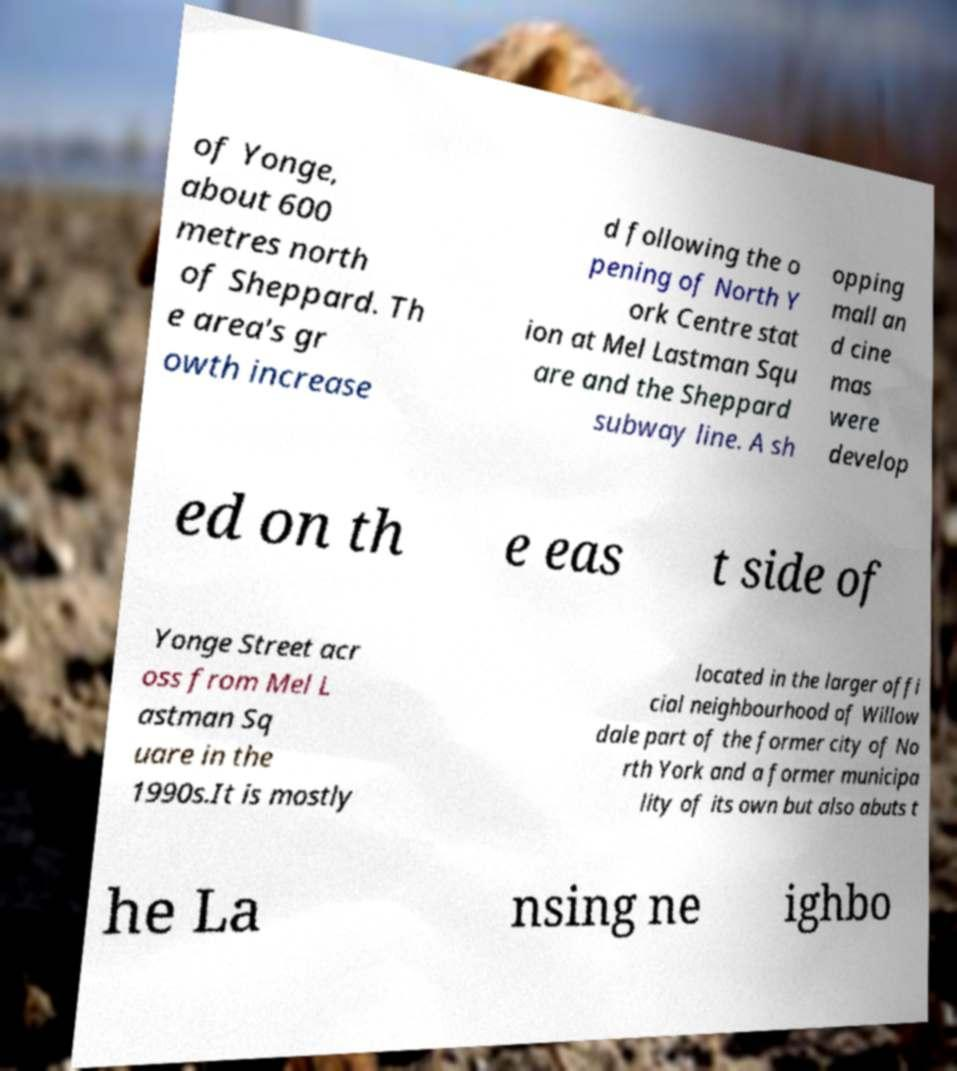Please read and relay the text visible in this image. What does it say? of Yonge, about 600 metres north of Sheppard. Th e area's gr owth increase d following the o pening of North Y ork Centre stat ion at Mel Lastman Squ are and the Sheppard subway line. A sh opping mall an d cine mas were develop ed on th e eas t side of Yonge Street acr oss from Mel L astman Sq uare in the 1990s.It is mostly located in the larger offi cial neighbourhood of Willow dale part of the former city of No rth York and a former municipa lity of its own but also abuts t he La nsing ne ighbo 